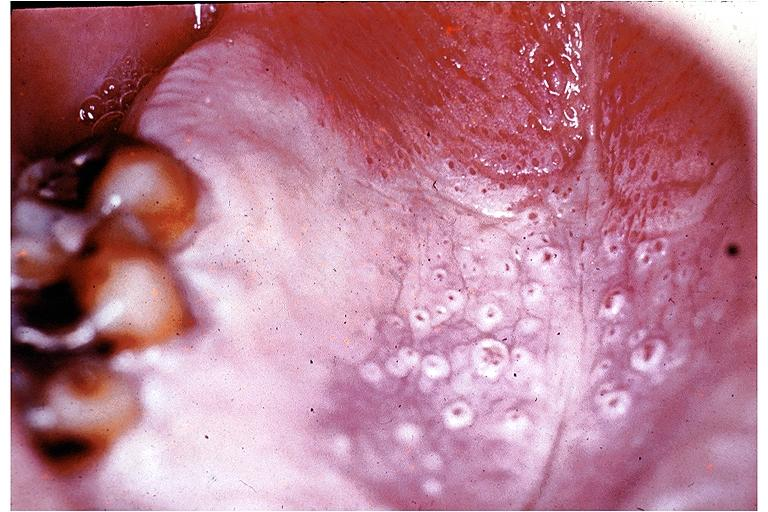s gaucher cell present?
Answer the question using a single word or phrase. No 